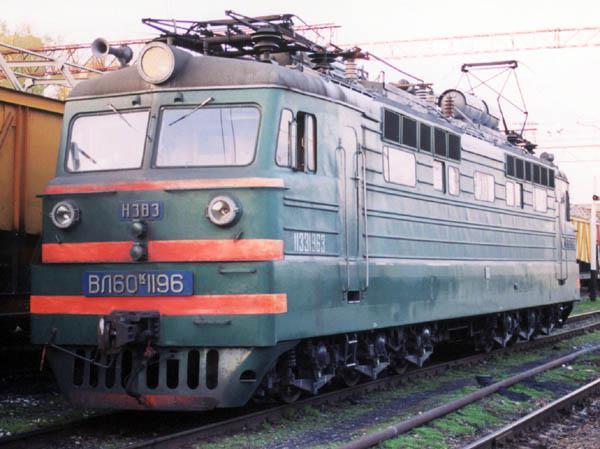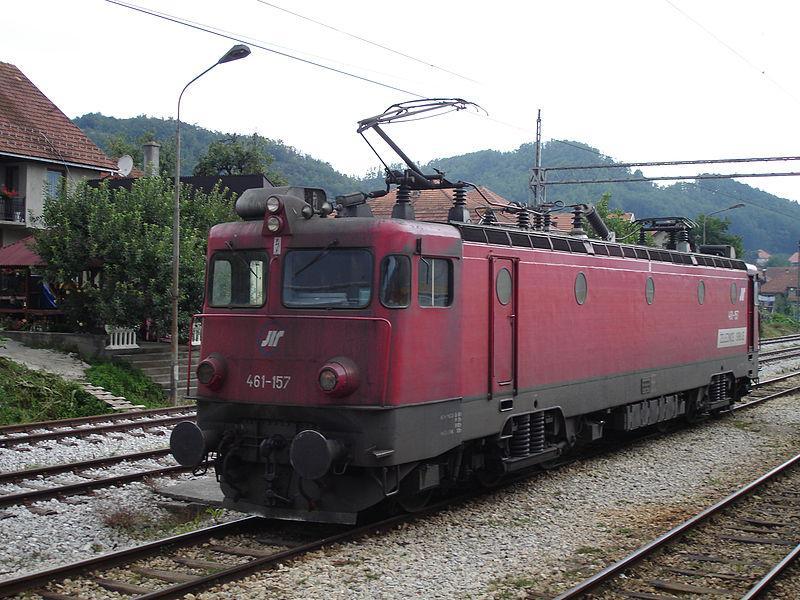The first image is the image on the left, the second image is the image on the right. Evaluate the accuracy of this statement regarding the images: "One image shows a red and white train angled to face leftward.". Is it true? Answer yes or no. No. The first image is the image on the left, the second image is the image on the right. Considering the images on both sides, is "the train in the image on the left does not have any round windows" valid? Answer yes or no. Yes. 